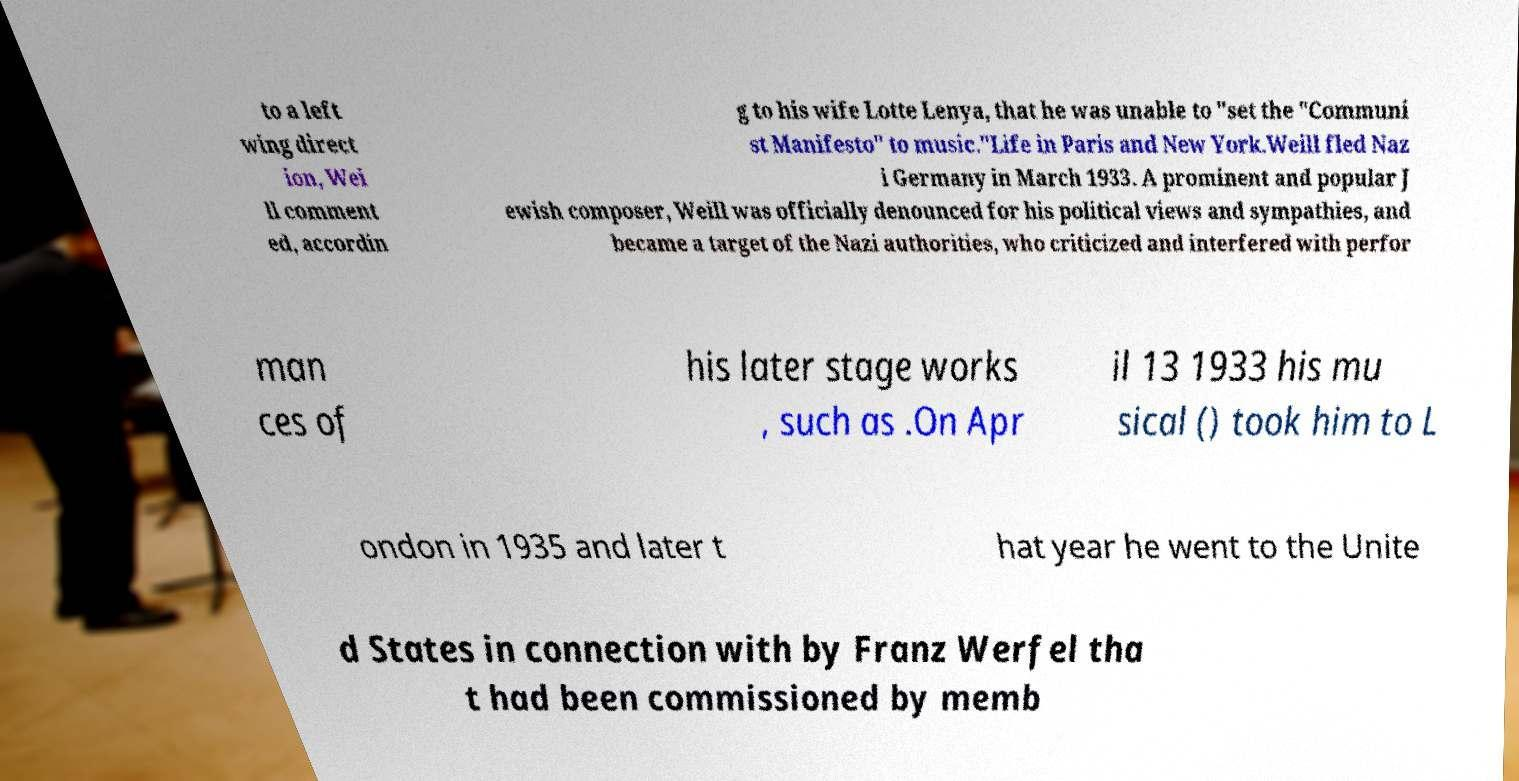Can you read and provide the text displayed in the image?This photo seems to have some interesting text. Can you extract and type it out for me? to a left wing direct ion, Wei ll comment ed, accordin g to his wife Lotte Lenya, that he was unable to "set the "Communi st Manifesto" to music."Life in Paris and New York.Weill fled Naz i Germany in March 1933. A prominent and popular J ewish composer, Weill was officially denounced for his political views and sympathies, and became a target of the Nazi authorities, who criticized and interfered with perfor man ces of his later stage works , such as .On Apr il 13 1933 his mu sical () took him to L ondon in 1935 and later t hat year he went to the Unite d States in connection with by Franz Werfel tha t had been commissioned by memb 